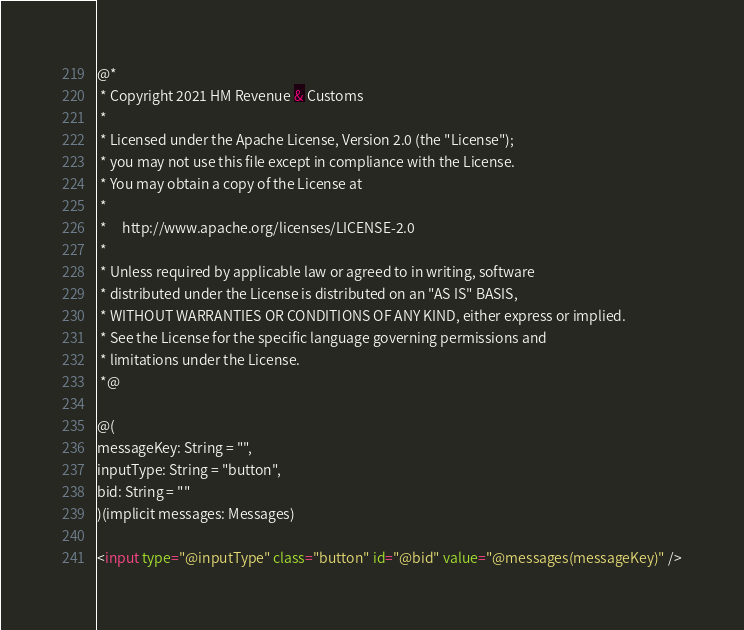Convert code to text. <code><loc_0><loc_0><loc_500><loc_500><_HTML_>@*
 * Copyright 2021 HM Revenue & Customs
 *
 * Licensed under the Apache License, Version 2.0 (the "License");
 * you may not use this file except in compliance with the License.
 * You may obtain a copy of the License at
 *
 *     http://www.apache.org/licenses/LICENSE-2.0
 *
 * Unless required by applicable law or agreed to in writing, software
 * distributed under the License is distributed on an "AS IS" BASIS,
 * WITHOUT WARRANTIES OR CONDITIONS OF ANY KIND, either express or implied.
 * See the License for the specific language governing permissions and
 * limitations under the License.
 *@

@(
messageKey: String = "",
inputType: String = "button",
bid: String = ""
)(implicit messages: Messages)

<input type="@inputType" class="button" id="@bid" value="@messages(messageKey)" />
</code> 